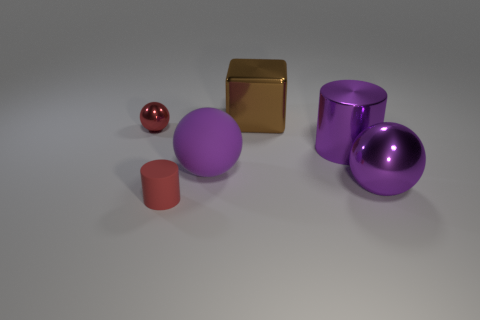Subtract all large spheres. How many spheres are left? 1 Subtract all cylinders. How many objects are left? 4 Add 2 big purple spheres. How many objects exist? 8 Add 6 matte things. How many matte things exist? 8 Subtract 0 green cylinders. How many objects are left? 6 Subtract all tiny rubber spheres. Subtract all big blocks. How many objects are left? 5 Add 3 small red metallic things. How many small red metallic things are left? 4 